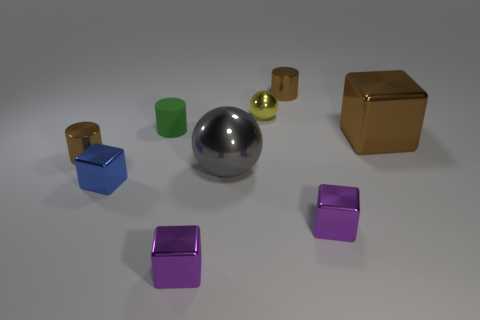Is there anything else that is the same shape as the yellow shiny thing?
Your answer should be very brief. Yes. What number of objects are cylinders behind the big cube or brown shiny spheres?
Give a very brief answer. 2. Does the small metallic cylinder behind the big metallic block have the same color as the small sphere?
Your response must be concise. No. What shape is the small thing that is to the right of the brown metal cylinder that is to the right of the tiny blue metallic block?
Offer a very short reply. Cube. Is the number of purple metal cubes that are behind the yellow thing less than the number of green cylinders on the left side of the tiny blue cube?
Provide a short and direct response. No. What size is the brown object that is the same shape as the tiny blue thing?
Offer a terse response. Large. Are there any other things that have the same size as the blue thing?
Keep it short and to the point. Yes. What number of things are brown shiny cylinders that are to the left of the tiny green matte cylinder or metallic cylinders that are to the right of the green rubber object?
Offer a very short reply. 2. Does the green thing have the same size as the gray metal thing?
Provide a short and direct response. No. Are there more tiny gray rubber blocks than gray metal balls?
Make the answer very short. No. 